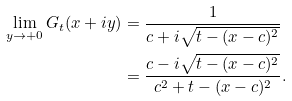Convert formula to latex. <formula><loc_0><loc_0><loc_500><loc_500>\lim _ { y \rightarrow + 0 } G _ { t } ( x + i y ) & = \frac { 1 } { c + i \sqrt { t - ( x - c ) ^ { 2 } } } \\ & = \frac { c - i \sqrt { t - ( x - c ) ^ { 2 } } } { c ^ { 2 } + t - ( x - c ) ^ { 2 } } .</formula> 